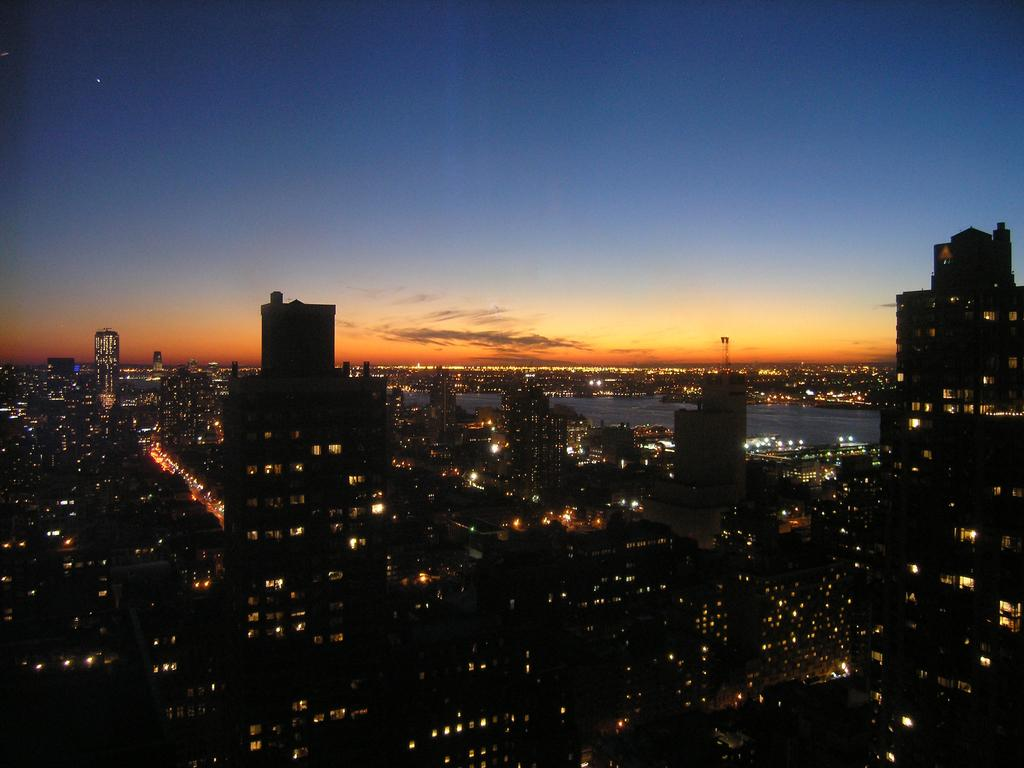What can be seen at the top of the image? The sky is visible in the image. What type of structures are present in the image? There are buildings in the image. What might be used for illumination in the image? Lights are present in the image. What is located in the middle portion of the image? There appears to be water in the middle portion of the image. What type of milk is being produced by the nation in the image? There is no mention of a nation or milk production in the image; it primarily features the sky, buildings, lights, and water. 